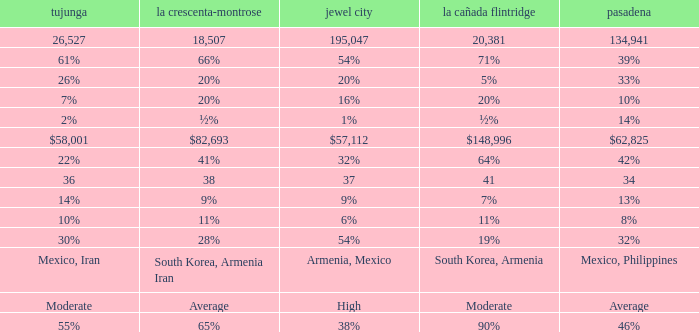What is the percentage of Tukunga when La Crescenta-Montrose is 28%? 30%. 